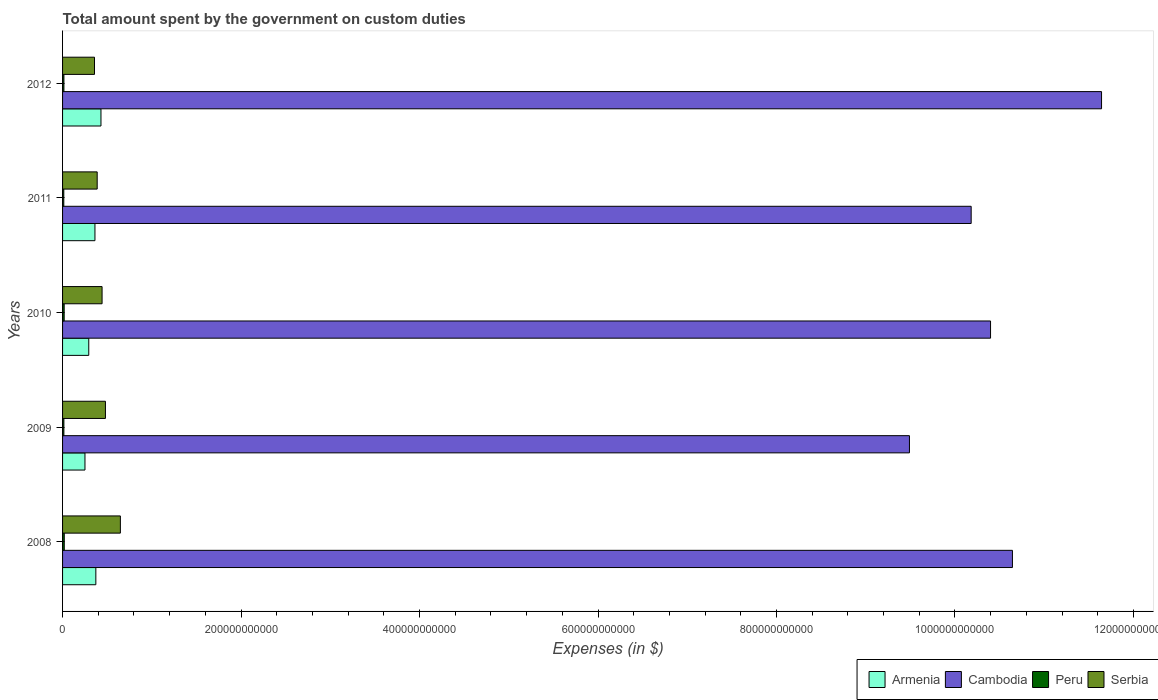How many groups of bars are there?
Your response must be concise. 5. Are the number of bars per tick equal to the number of legend labels?
Your response must be concise. Yes. Are the number of bars on each tick of the Y-axis equal?
Keep it short and to the point. Yes. In how many cases, is the number of bars for a given year not equal to the number of legend labels?
Provide a short and direct response. 0. What is the amount spent on custom duties by the government in Armenia in 2011?
Keep it short and to the point. 3.63e+1. Across all years, what is the maximum amount spent on custom duties by the government in Cambodia?
Your response must be concise. 1.16e+12. Across all years, what is the minimum amount spent on custom duties by the government in Cambodia?
Give a very brief answer. 9.49e+11. In which year was the amount spent on custom duties by the government in Serbia maximum?
Provide a succinct answer. 2008. What is the total amount spent on custom duties by the government in Serbia in the graph?
Your answer should be very brief. 2.32e+11. What is the difference between the amount spent on custom duties by the government in Serbia in 2008 and that in 2010?
Your response must be concise. 2.05e+1. What is the difference between the amount spent on custom duties by the government in Cambodia in 2010 and the amount spent on custom duties by the government in Armenia in 2011?
Offer a very short reply. 1.00e+12. What is the average amount spent on custom duties by the government in Serbia per year?
Make the answer very short. 4.63e+1. In the year 2009, what is the difference between the amount spent on custom duties by the government in Cambodia and amount spent on custom duties by the government in Armenia?
Keep it short and to the point. 9.24e+11. In how many years, is the amount spent on custom duties by the government in Serbia greater than 1000000000000 $?
Make the answer very short. 0. What is the ratio of the amount spent on custom duties by the government in Cambodia in 2010 to that in 2011?
Offer a very short reply. 1.02. Is the amount spent on custom duties by the government in Armenia in 2009 less than that in 2010?
Give a very brief answer. Yes. Is the difference between the amount spent on custom duties by the government in Cambodia in 2008 and 2012 greater than the difference between the amount spent on custom duties by the government in Armenia in 2008 and 2012?
Your answer should be very brief. No. What is the difference between the highest and the second highest amount spent on custom duties by the government in Armenia?
Offer a terse response. 5.75e+09. What is the difference between the highest and the lowest amount spent on custom duties by the government in Armenia?
Offer a very short reply. 1.79e+1. Is it the case that in every year, the sum of the amount spent on custom duties by the government in Serbia and amount spent on custom duties by the government in Peru is greater than the sum of amount spent on custom duties by the government in Armenia and amount spent on custom duties by the government in Cambodia?
Keep it short and to the point. No. What does the 1st bar from the top in 2011 represents?
Your response must be concise. Serbia. What does the 4th bar from the bottom in 2010 represents?
Make the answer very short. Serbia. Is it the case that in every year, the sum of the amount spent on custom duties by the government in Cambodia and amount spent on custom duties by the government in Serbia is greater than the amount spent on custom duties by the government in Armenia?
Ensure brevity in your answer.  Yes. What is the difference between two consecutive major ticks on the X-axis?
Your answer should be compact. 2.00e+11. Are the values on the major ticks of X-axis written in scientific E-notation?
Keep it short and to the point. No. How are the legend labels stacked?
Offer a terse response. Horizontal. What is the title of the graph?
Give a very brief answer. Total amount spent by the government on custom duties. Does "Yemen, Rep." appear as one of the legend labels in the graph?
Your response must be concise. No. What is the label or title of the X-axis?
Provide a short and direct response. Expenses (in $). What is the Expenses (in $) in Armenia in 2008?
Ensure brevity in your answer.  3.73e+1. What is the Expenses (in $) in Cambodia in 2008?
Keep it short and to the point. 1.06e+12. What is the Expenses (in $) in Peru in 2008?
Offer a terse response. 1.91e+09. What is the Expenses (in $) of Serbia in 2008?
Give a very brief answer. 6.48e+1. What is the Expenses (in $) in Armenia in 2009?
Offer a terse response. 2.51e+1. What is the Expenses (in $) of Cambodia in 2009?
Ensure brevity in your answer.  9.49e+11. What is the Expenses (in $) in Peru in 2009?
Keep it short and to the point. 1.49e+09. What is the Expenses (in $) of Serbia in 2009?
Provide a succinct answer. 4.80e+1. What is the Expenses (in $) of Armenia in 2010?
Make the answer very short. 2.94e+1. What is the Expenses (in $) of Cambodia in 2010?
Provide a succinct answer. 1.04e+12. What is the Expenses (in $) in Peru in 2010?
Your answer should be compact. 1.80e+09. What is the Expenses (in $) in Serbia in 2010?
Your answer should be compact. 4.43e+1. What is the Expenses (in $) in Armenia in 2011?
Your response must be concise. 3.63e+1. What is the Expenses (in $) in Cambodia in 2011?
Make the answer very short. 1.02e+12. What is the Expenses (in $) of Peru in 2011?
Make the answer very short. 1.38e+09. What is the Expenses (in $) of Serbia in 2011?
Make the answer very short. 3.88e+1. What is the Expenses (in $) in Armenia in 2012?
Offer a terse response. 4.30e+1. What is the Expenses (in $) of Cambodia in 2012?
Give a very brief answer. 1.16e+12. What is the Expenses (in $) of Peru in 2012?
Offer a terse response. 1.53e+09. What is the Expenses (in $) of Serbia in 2012?
Ensure brevity in your answer.  3.58e+1. Across all years, what is the maximum Expenses (in $) in Armenia?
Your answer should be very brief. 4.30e+1. Across all years, what is the maximum Expenses (in $) of Cambodia?
Keep it short and to the point. 1.16e+12. Across all years, what is the maximum Expenses (in $) in Peru?
Offer a very short reply. 1.91e+09. Across all years, what is the maximum Expenses (in $) of Serbia?
Keep it short and to the point. 6.48e+1. Across all years, what is the minimum Expenses (in $) in Armenia?
Your answer should be very brief. 2.51e+1. Across all years, what is the minimum Expenses (in $) in Cambodia?
Offer a very short reply. 9.49e+11. Across all years, what is the minimum Expenses (in $) in Peru?
Your response must be concise. 1.38e+09. Across all years, what is the minimum Expenses (in $) of Serbia?
Your answer should be compact. 3.58e+1. What is the total Expenses (in $) in Armenia in the graph?
Your response must be concise. 1.71e+11. What is the total Expenses (in $) of Cambodia in the graph?
Offer a terse response. 5.24e+12. What is the total Expenses (in $) in Peru in the graph?
Keep it short and to the point. 8.11e+09. What is the total Expenses (in $) of Serbia in the graph?
Keep it short and to the point. 2.32e+11. What is the difference between the Expenses (in $) of Armenia in 2008 and that in 2009?
Your response must be concise. 1.22e+1. What is the difference between the Expenses (in $) in Cambodia in 2008 and that in 2009?
Your response must be concise. 1.15e+11. What is the difference between the Expenses (in $) of Peru in 2008 and that in 2009?
Give a very brief answer. 4.18e+08. What is the difference between the Expenses (in $) in Serbia in 2008 and that in 2009?
Ensure brevity in your answer.  1.67e+1. What is the difference between the Expenses (in $) in Armenia in 2008 and that in 2010?
Your answer should be very brief. 7.92e+09. What is the difference between the Expenses (in $) of Cambodia in 2008 and that in 2010?
Make the answer very short. 2.45e+1. What is the difference between the Expenses (in $) in Peru in 2008 and that in 2010?
Offer a very short reply. 1.08e+08. What is the difference between the Expenses (in $) in Serbia in 2008 and that in 2010?
Make the answer very short. 2.05e+1. What is the difference between the Expenses (in $) in Armenia in 2008 and that in 2011?
Provide a short and direct response. 1.00e+09. What is the difference between the Expenses (in $) of Cambodia in 2008 and that in 2011?
Offer a very short reply. 4.62e+1. What is the difference between the Expenses (in $) in Peru in 2008 and that in 2011?
Your answer should be compact. 5.30e+08. What is the difference between the Expenses (in $) in Serbia in 2008 and that in 2011?
Your answer should be compact. 2.60e+1. What is the difference between the Expenses (in $) of Armenia in 2008 and that in 2012?
Offer a very short reply. -5.75e+09. What is the difference between the Expenses (in $) in Cambodia in 2008 and that in 2012?
Give a very brief answer. -9.98e+1. What is the difference between the Expenses (in $) of Peru in 2008 and that in 2012?
Your answer should be compact. 3.85e+08. What is the difference between the Expenses (in $) in Serbia in 2008 and that in 2012?
Provide a short and direct response. 2.90e+1. What is the difference between the Expenses (in $) in Armenia in 2009 and that in 2010?
Your answer should be very brief. -4.26e+09. What is the difference between the Expenses (in $) of Cambodia in 2009 and that in 2010?
Your answer should be compact. -9.09e+1. What is the difference between the Expenses (in $) of Peru in 2009 and that in 2010?
Provide a succinct answer. -3.10e+08. What is the difference between the Expenses (in $) in Serbia in 2009 and that in 2010?
Provide a succinct answer. 3.75e+09. What is the difference between the Expenses (in $) of Armenia in 2009 and that in 2011?
Ensure brevity in your answer.  -1.12e+1. What is the difference between the Expenses (in $) in Cambodia in 2009 and that in 2011?
Ensure brevity in your answer.  -6.92e+1. What is the difference between the Expenses (in $) of Peru in 2009 and that in 2011?
Provide a short and direct response. 1.12e+08. What is the difference between the Expenses (in $) in Serbia in 2009 and that in 2011?
Provide a succinct answer. 9.24e+09. What is the difference between the Expenses (in $) of Armenia in 2009 and that in 2012?
Offer a very short reply. -1.79e+1. What is the difference between the Expenses (in $) of Cambodia in 2009 and that in 2012?
Ensure brevity in your answer.  -2.15e+11. What is the difference between the Expenses (in $) in Peru in 2009 and that in 2012?
Ensure brevity in your answer.  -3.32e+07. What is the difference between the Expenses (in $) of Serbia in 2009 and that in 2012?
Provide a short and direct response. 1.23e+1. What is the difference between the Expenses (in $) in Armenia in 2010 and that in 2011?
Provide a succinct answer. -6.92e+09. What is the difference between the Expenses (in $) of Cambodia in 2010 and that in 2011?
Give a very brief answer. 2.17e+1. What is the difference between the Expenses (in $) in Peru in 2010 and that in 2011?
Your answer should be very brief. 4.23e+08. What is the difference between the Expenses (in $) in Serbia in 2010 and that in 2011?
Offer a very short reply. 5.48e+09. What is the difference between the Expenses (in $) in Armenia in 2010 and that in 2012?
Ensure brevity in your answer.  -1.37e+1. What is the difference between the Expenses (in $) of Cambodia in 2010 and that in 2012?
Keep it short and to the point. -1.24e+11. What is the difference between the Expenses (in $) of Peru in 2010 and that in 2012?
Your response must be concise. 2.77e+08. What is the difference between the Expenses (in $) in Serbia in 2010 and that in 2012?
Your answer should be very brief. 8.50e+09. What is the difference between the Expenses (in $) of Armenia in 2011 and that in 2012?
Keep it short and to the point. -6.75e+09. What is the difference between the Expenses (in $) in Cambodia in 2011 and that in 2012?
Give a very brief answer. -1.46e+11. What is the difference between the Expenses (in $) of Peru in 2011 and that in 2012?
Your answer should be very brief. -1.46e+08. What is the difference between the Expenses (in $) of Serbia in 2011 and that in 2012?
Your answer should be very brief. 3.02e+09. What is the difference between the Expenses (in $) in Armenia in 2008 and the Expenses (in $) in Cambodia in 2009?
Offer a terse response. -9.12e+11. What is the difference between the Expenses (in $) in Armenia in 2008 and the Expenses (in $) in Peru in 2009?
Keep it short and to the point. 3.58e+1. What is the difference between the Expenses (in $) in Armenia in 2008 and the Expenses (in $) in Serbia in 2009?
Provide a short and direct response. -1.07e+1. What is the difference between the Expenses (in $) of Cambodia in 2008 and the Expenses (in $) of Peru in 2009?
Ensure brevity in your answer.  1.06e+12. What is the difference between the Expenses (in $) in Cambodia in 2008 and the Expenses (in $) in Serbia in 2009?
Provide a succinct answer. 1.02e+12. What is the difference between the Expenses (in $) in Peru in 2008 and the Expenses (in $) in Serbia in 2009?
Provide a succinct answer. -4.61e+1. What is the difference between the Expenses (in $) in Armenia in 2008 and the Expenses (in $) in Cambodia in 2010?
Provide a succinct answer. -1.00e+12. What is the difference between the Expenses (in $) in Armenia in 2008 and the Expenses (in $) in Peru in 2010?
Your response must be concise. 3.55e+1. What is the difference between the Expenses (in $) in Armenia in 2008 and the Expenses (in $) in Serbia in 2010?
Your answer should be very brief. -7.00e+09. What is the difference between the Expenses (in $) of Cambodia in 2008 and the Expenses (in $) of Peru in 2010?
Your answer should be very brief. 1.06e+12. What is the difference between the Expenses (in $) of Cambodia in 2008 and the Expenses (in $) of Serbia in 2010?
Keep it short and to the point. 1.02e+12. What is the difference between the Expenses (in $) of Peru in 2008 and the Expenses (in $) of Serbia in 2010?
Provide a short and direct response. -4.24e+1. What is the difference between the Expenses (in $) of Armenia in 2008 and the Expenses (in $) of Cambodia in 2011?
Ensure brevity in your answer.  -9.81e+11. What is the difference between the Expenses (in $) in Armenia in 2008 and the Expenses (in $) in Peru in 2011?
Make the answer very short. 3.59e+1. What is the difference between the Expenses (in $) in Armenia in 2008 and the Expenses (in $) in Serbia in 2011?
Offer a terse response. -1.51e+09. What is the difference between the Expenses (in $) in Cambodia in 2008 and the Expenses (in $) in Peru in 2011?
Give a very brief answer. 1.06e+12. What is the difference between the Expenses (in $) in Cambodia in 2008 and the Expenses (in $) in Serbia in 2011?
Make the answer very short. 1.03e+12. What is the difference between the Expenses (in $) in Peru in 2008 and the Expenses (in $) in Serbia in 2011?
Offer a terse response. -3.69e+1. What is the difference between the Expenses (in $) in Armenia in 2008 and the Expenses (in $) in Cambodia in 2012?
Offer a very short reply. -1.13e+12. What is the difference between the Expenses (in $) in Armenia in 2008 and the Expenses (in $) in Peru in 2012?
Provide a short and direct response. 3.58e+1. What is the difference between the Expenses (in $) in Armenia in 2008 and the Expenses (in $) in Serbia in 2012?
Offer a terse response. 1.51e+09. What is the difference between the Expenses (in $) of Cambodia in 2008 and the Expenses (in $) of Peru in 2012?
Your answer should be very brief. 1.06e+12. What is the difference between the Expenses (in $) in Cambodia in 2008 and the Expenses (in $) in Serbia in 2012?
Your response must be concise. 1.03e+12. What is the difference between the Expenses (in $) in Peru in 2008 and the Expenses (in $) in Serbia in 2012?
Offer a very short reply. -3.39e+1. What is the difference between the Expenses (in $) in Armenia in 2009 and the Expenses (in $) in Cambodia in 2010?
Give a very brief answer. -1.01e+12. What is the difference between the Expenses (in $) of Armenia in 2009 and the Expenses (in $) of Peru in 2010?
Ensure brevity in your answer.  2.33e+1. What is the difference between the Expenses (in $) in Armenia in 2009 and the Expenses (in $) in Serbia in 2010?
Offer a very short reply. -1.92e+1. What is the difference between the Expenses (in $) of Cambodia in 2009 and the Expenses (in $) of Peru in 2010?
Your answer should be very brief. 9.47e+11. What is the difference between the Expenses (in $) in Cambodia in 2009 and the Expenses (in $) in Serbia in 2010?
Your answer should be compact. 9.05e+11. What is the difference between the Expenses (in $) of Peru in 2009 and the Expenses (in $) of Serbia in 2010?
Give a very brief answer. -4.28e+1. What is the difference between the Expenses (in $) in Armenia in 2009 and the Expenses (in $) in Cambodia in 2011?
Offer a terse response. -9.93e+11. What is the difference between the Expenses (in $) in Armenia in 2009 and the Expenses (in $) in Peru in 2011?
Give a very brief answer. 2.37e+1. What is the difference between the Expenses (in $) in Armenia in 2009 and the Expenses (in $) in Serbia in 2011?
Your answer should be compact. -1.37e+1. What is the difference between the Expenses (in $) of Cambodia in 2009 and the Expenses (in $) of Peru in 2011?
Provide a short and direct response. 9.48e+11. What is the difference between the Expenses (in $) in Cambodia in 2009 and the Expenses (in $) in Serbia in 2011?
Make the answer very short. 9.10e+11. What is the difference between the Expenses (in $) in Peru in 2009 and the Expenses (in $) in Serbia in 2011?
Offer a terse response. -3.73e+1. What is the difference between the Expenses (in $) of Armenia in 2009 and the Expenses (in $) of Cambodia in 2012?
Give a very brief answer. -1.14e+12. What is the difference between the Expenses (in $) in Armenia in 2009 and the Expenses (in $) in Peru in 2012?
Make the answer very short. 2.36e+1. What is the difference between the Expenses (in $) in Armenia in 2009 and the Expenses (in $) in Serbia in 2012?
Provide a succinct answer. -1.07e+1. What is the difference between the Expenses (in $) of Cambodia in 2009 and the Expenses (in $) of Peru in 2012?
Your response must be concise. 9.47e+11. What is the difference between the Expenses (in $) of Cambodia in 2009 and the Expenses (in $) of Serbia in 2012?
Your response must be concise. 9.13e+11. What is the difference between the Expenses (in $) in Peru in 2009 and the Expenses (in $) in Serbia in 2012?
Keep it short and to the point. -3.43e+1. What is the difference between the Expenses (in $) in Armenia in 2010 and the Expenses (in $) in Cambodia in 2011?
Keep it short and to the point. -9.89e+11. What is the difference between the Expenses (in $) in Armenia in 2010 and the Expenses (in $) in Peru in 2011?
Give a very brief answer. 2.80e+1. What is the difference between the Expenses (in $) in Armenia in 2010 and the Expenses (in $) in Serbia in 2011?
Offer a very short reply. -9.44e+09. What is the difference between the Expenses (in $) in Cambodia in 2010 and the Expenses (in $) in Peru in 2011?
Provide a short and direct response. 1.04e+12. What is the difference between the Expenses (in $) in Cambodia in 2010 and the Expenses (in $) in Serbia in 2011?
Offer a terse response. 1.00e+12. What is the difference between the Expenses (in $) of Peru in 2010 and the Expenses (in $) of Serbia in 2011?
Your response must be concise. -3.70e+1. What is the difference between the Expenses (in $) of Armenia in 2010 and the Expenses (in $) of Cambodia in 2012?
Keep it short and to the point. -1.13e+12. What is the difference between the Expenses (in $) of Armenia in 2010 and the Expenses (in $) of Peru in 2012?
Keep it short and to the point. 2.78e+1. What is the difference between the Expenses (in $) in Armenia in 2010 and the Expenses (in $) in Serbia in 2012?
Offer a very short reply. -6.42e+09. What is the difference between the Expenses (in $) in Cambodia in 2010 and the Expenses (in $) in Peru in 2012?
Make the answer very short. 1.04e+12. What is the difference between the Expenses (in $) of Cambodia in 2010 and the Expenses (in $) of Serbia in 2012?
Give a very brief answer. 1.00e+12. What is the difference between the Expenses (in $) in Peru in 2010 and the Expenses (in $) in Serbia in 2012?
Your answer should be compact. -3.40e+1. What is the difference between the Expenses (in $) of Armenia in 2011 and the Expenses (in $) of Cambodia in 2012?
Your answer should be compact. -1.13e+12. What is the difference between the Expenses (in $) of Armenia in 2011 and the Expenses (in $) of Peru in 2012?
Make the answer very short. 3.48e+1. What is the difference between the Expenses (in $) of Armenia in 2011 and the Expenses (in $) of Serbia in 2012?
Your response must be concise. 5.07e+08. What is the difference between the Expenses (in $) in Cambodia in 2011 and the Expenses (in $) in Peru in 2012?
Offer a very short reply. 1.02e+12. What is the difference between the Expenses (in $) in Cambodia in 2011 and the Expenses (in $) in Serbia in 2012?
Your response must be concise. 9.82e+11. What is the difference between the Expenses (in $) in Peru in 2011 and the Expenses (in $) in Serbia in 2012?
Keep it short and to the point. -3.44e+1. What is the average Expenses (in $) of Armenia per year?
Give a very brief answer. 3.42e+1. What is the average Expenses (in $) in Cambodia per year?
Provide a short and direct response. 1.05e+12. What is the average Expenses (in $) of Peru per year?
Keep it short and to the point. 1.62e+09. What is the average Expenses (in $) in Serbia per year?
Your response must be concise. 4.63e+1. In the year 2008, what is the difference between the Expenses (in $) of Armenia and Expenses (in $) of Cambodia?
Give a very brief answer. -1.03e+12. In the year 2008, what is the difference between the Expenses (in $) of Armenia and Expenses (in $) of Peru?
Keep it short and to the point. 3.54e+1. In the year 2008, what is the difference between the Expenses (in $) of Armenia and Expenses (in $) of Serbia?
Keep it short and to the point. -2.75e+1. In the year 2008, what is the difference between the Expenses (in $) of Cambodia and Expenses (in $) of Peru?
Keep it short and to the point. 1.06e+12. In the year 2008, what is the difference between the Expenses (in $) in Cambodia and Expenses (in $) in Serbia?
Offer a terse response. 1.00e+12. In the year 2008, what is the difference between the Expenses (in $) of Peru and Expenses (in $) of Serbia?
Keep it short and to the point. -6.29e+1. In the year 2009, what is the difference between the Expenses (in $) of Armenia and Expenses (in $) of Cambodia?
Ensure brevity in your answer.  -9.24e+11. In the year 2009, what is the difference between the Expenses (in $) of Armenia and Expenses (in $) of Peru?
Provide a short and direct response. 2.36e+1. In the year 2009, what is the difference between the Expenses (in $) of Armenia and Expenses (in $) of Serbia?
Your answer should be compact. -2.29e+1. In the year 2009, what is the difference between the Expenses (in $) of Cambodia and Expenses (in $) of Peru?
Offer a very short reply. 9.48e+11. In the year 2009, what is the difference between the Expenses (in $) of Cambodia and Expenses (in $) of Serbia?
Make the answer very short. 9.01e+11. In the year 2009, what is the difference between the Expenses (in $) of Peru and Expenses (in $) of Serbia?
Your response must be concise. -4.65e+1. In the year 2010, what is the difference between the Expenses (in $) of Armenia and Expenses (in $) of Cambodia?
Your answer should be very brief. -1.01e+12. In the year 2010, what is the difference between the Expenses (in $) in Armenia and Expenses (in $) in Peru?
Your answer should be compact. 2.76e+1. In the year 2010, what is the difference between the Expenses (in $) of Armenia and Expenses (in $) of Serbia?
Your answer should be very brief. -1.49e+1. In the year 2010, what is the difference between the Expenses (in $) of Cambodia and Expenses (in $) of Peru?
Provide a short and direct response. 1.04e+12. In the year 2010, what is the difference between the Expenses (in $) in Cambodia and Expenses (in $) in Serbia?
Provide a succinct answer. 9.96e+11. In the year 2010, what is the difference between the Expenses (in $) of Peru and Expenses (in $) of Serbia?
Offer a very short reply. -4.25e+1. In the year 2011, what is the difference between the Expenses (in $) in Armenia and Expenses (in $) in Cambodia?
Keep it short and to the point. -9.82e+11. In the year 2011, what is the difference between the Expenses (in $) of Armenia and Expenses (in $) of Peru?
Make the answer very short. 3.49e+1. In the year 2011, what is the difference between the Expenses (in $) in Armenia and Expenses (in $) in Serbia?
Give a very brief answer. -2.52e+09. In the year 2011, what is the difference between the Expenses (in $) in Cambodia and Expenses (in $) in Peru?
Keep it short and to the point. 1.02e+12. In the year 2011, what is the difference between the Expenses (in $) in Cambodia and Expenses (in $) in Serbia?
Make the answer very short. 9.79e+11. In the year 2011, what is the difference between the Expenses (in $) in Peru and Expenses (in $) in Serbia?
Your response must be concise. -3.74e+1. In the year 2012, what is the difference between the Expenses (in $) of Armenia and Expenses (in $) of Cambodia?
Your response must be concise. -1.12e+12. In the year 2012, what is the difference between the Expenses (in $) in Armenia and Expenses (in $) in Peru?
Keep it short and to the point. 4.15e+1. In the year 2012, what is the difference between the Expenses (in $) in Armenia and Expenses (in $) in Serbia?
Provide a succinct answer. 7.26e+09. In the year 2012, what is the difference between the Expenses (in $) of Cambodia and Expenses (in $) of Peru?
Keep it short and to the point. 1.16e+12. In the year 2012, what is the difference between the Expenses (in $) of Cambodia and Expenses (in $) of Serbia?
Your answer should be very brief. 1.13e+12. In the year 2012, what is the difference between the Expenses (in $) in Peru and Expenses (in $) in Serbia?
Your response must be concise. -3.43e+1. What is the ratio of the Expenses (in $) in Armenia in 2008 to that in 2009?
Give a very brief answer. 1.49. What is the ratio of the Expenses (in $) in Cambodia in 2008 to that in 2009?
Ensure brevity in your answer.  1.12. What is the ratio of the Expenses (in $) in Peru in 2008 to that in 2009?
Offer a terse response. 1.28. What is the ratio of the Expenses (in $) in Serbia in 2008 to that in 2009?
Ensure brevity in your answer.  1.35. What is the ratio of the Expenses (in $) in Armenia in 2008 to that in 2010?
Keep it short and to the point. 1.27. What is the ratio of the Expenses (in $) of Cambodia in 2008 to that in 2010?
Keep it short and to the point. 1.02. What is the ratio of the Expenses (in $) in Peru in 2008 to that in 2010?
Your response must be concise. 1.06. What is the ratio of the Expenses (in $) of Serbia in 2008 to that in 2010?
Offer a very short reply. 1.46. What is the ratio of the Expenses (in $) in Armenia in 2008 to that in 2011?
Give a very brief answer. 1.03. What is the ratio of the Expenses (in $) of Cambodia in 2008 to that in 2011?
Provide a short and direct response. 1.05. What is the ratio of the Expenses (in $) of Peru in 2008 to that in 2011?
Provide a succinct answer. 1.38. What is the ratio of the Expenses (in $) of Serbia in 2008 to that in 2011?
Your response must be concise. 1.67. What is the ratio of the Expenses (in $) of Armenia in 2008 to that in 2012?
Ensure brevity in your answer.  0.87. What is the ratio of the Expenses (in $) in Cambodia in 2008 to that in 2012?
Offer a terse response. 0.91. What is the ratio of the Expenses (in $) of Peru in 2008 to that in 2012?
Offer a terse response. 1.25. What is the ratio of the Expenses (in $) in Serbia in 2008 to that in 2012?
Ensure brevity in your answer.  1.81. What is the ratio of the Expenses (in $) of Armenia in 2009 to that in 2010?
Provide a short and direct response. 0.86. What is the ratio of the Expenses (in $) of Cambodia in 2009 to that in 2010?
Offer a very short reply. 0.91. What is the ratio of the Expenses (in $) of Peru in 2009 to that in 2010?
Your response must be concise. 0.83. What is the ratio of the Expenses (in $) in Serbia in 2009 to that in 2010?
Give a very brief answer. 1.08. What is the ratio of the Expenses (in $) of Armenia in 2009 to that in 2011?
Your answer should be very brief. 0.69. What is the ratio of the Expenses (in $) of Cambodia in 2009 to that in 2011?
Give a very brief answer. 0.93. What is the ratio of the Expenses (in $) in Peru in 2009 to that in 2011?
Ensure brevity in your answer.  1.08. What is the ratio of the Expenses (in $) of Serbia in 2009 to that in 2011?
Make the answer very short. 1.24. What is the ratio of the Expenses (in $) in Armenia in 2009 to that in 2012?
Offer a very short reply. 0.58. What is the ratio of the Expenses (in $) of Cambodia in 2009 to that in 2012?
Offer a very short reply. 0.82. What is the ratio of the Expenses (in $) in Peru in 2009 to that in 2012?
Your answer should be compact. 0.98. What is the ratio of the Expenses (in $) of Serbia in 2009 to that in 2012?
Provide a short and direct response. 1.34. What is the ratio of the Expenses (in $) in Armenia in 2010 to that in 2011?
Keep it short and to the point. 0.81. What is the ratio of the Expenses (in $) in Cambodia in 2010 to that in 2011?
Your answer should be compact. 1.02. What is the ratio of the Expenses (in $) in Peru in 2010 to that in 2011?
Give a very brief answer. 1.31. What is the ratio of the Expenses (in $) in Serbia in 2010 to that in 2011?
Offer a very short reply. 1.14. What is the ratio of the Expenses (in $) of Armenia in 2010 to that in 2012?
Your response must be concise. 0.68. What is the ratio of the Expenses (in $) in Cambodia in 2010 to that in 2012?
Give a very brief answer. 0.89. What is the ratio of the Expenses (in $) in Peru in 2010 to that in 2012?
Provide a succinct answer. 1.18. What is the ratio of the Expenses (in $) of Serbia in 2010 to that in 2012?
Give a very brief answer. 1.24. What is the ratio of the Expenses (in $) of Armenia in 2011 to that in 2012?
Your response must be concise. 0.84. What is the ratio of the Expenses (in $) in Cambodia in 2011 to that in 2012?
Provide a succinct answer. 0.87. What is the ratio of the Expenses (in $) in Peru in 2011 to that in 2012?
Offer a very short reply. 0.9. What is the ratio of the Expenses (in $) in Serbia in 2011 to that in 2012?
Make the answer very short. 1.08. What is the difference between the highest and the second highest Expenses (in $) of Armenia?
Keep it short and to the point. 5.75e+09. What is the difference between the highest and the second highest Expenses (in $) in Cambodia?
Offer a terse response. 9.98e+1. What is the difference between the highest and the second highest Expenses (in $) of Peru?
Provide a succinct answer. 1.08e+08. What is the difference between the highest and the second highest Expenses (in $) in Serbia?
Ensure brevity in your answer.  1.67e+1. What is the difference between the highest and the lowest Expenses (in $) of Armenia?
Make the answer very short. 1.79e+1. What is the difference between the highest and the lowest Expenses (in $) in Cambodia?
Provide a succinct answer. 2.15e+11. What is the difference between the highest and the lowest Expenses (in $) in Peru?
Provide a short and direct response. 5.30e+08. What is the difference between the highest and the lowest Expenses (in $) in Serbia?
Keep it short and to the point. 2.90e+1. 